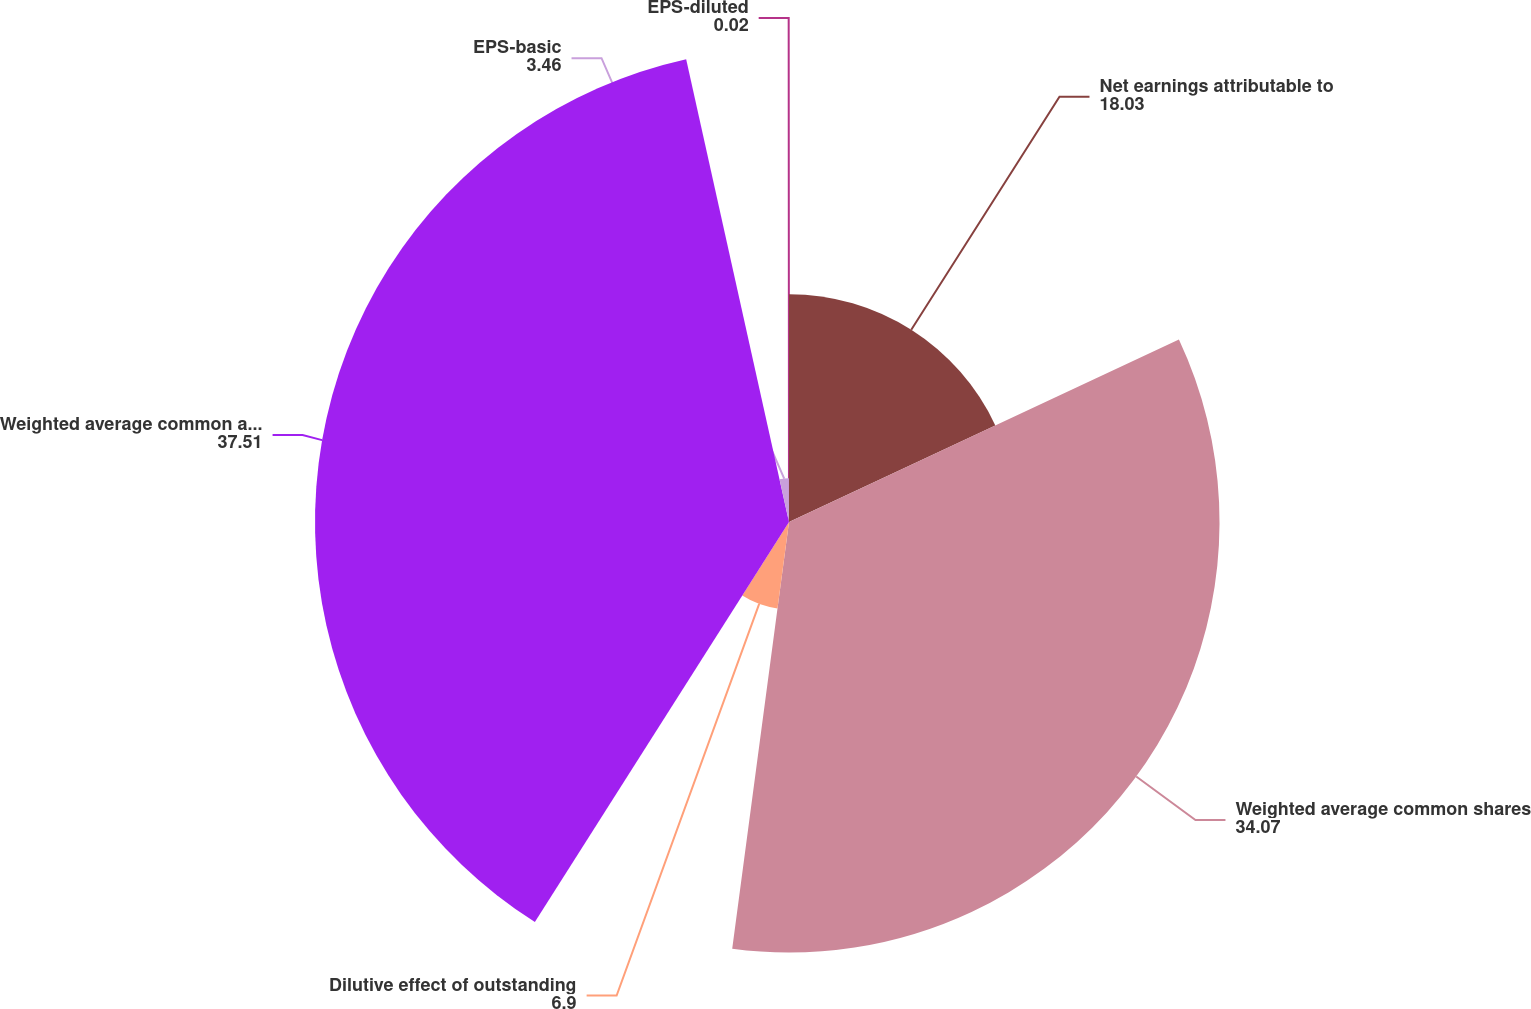Convert chart. <chart><loc_0><loc_0><loc_500><loc_500><pie_chart><fcel>Net earnings attributable to<fcel>Weighted average common shares<fcel>Dilutive effect of outstanding<fcel>Weighted average common and<fcel>EPS-basic<fcel>EPS-diluted<nl><fcel>18.03%<fcel>34.07%<fcel>6.9%<fcel>37.51%<fcel>3.46%<fcel>0.02%<nl></chart> 